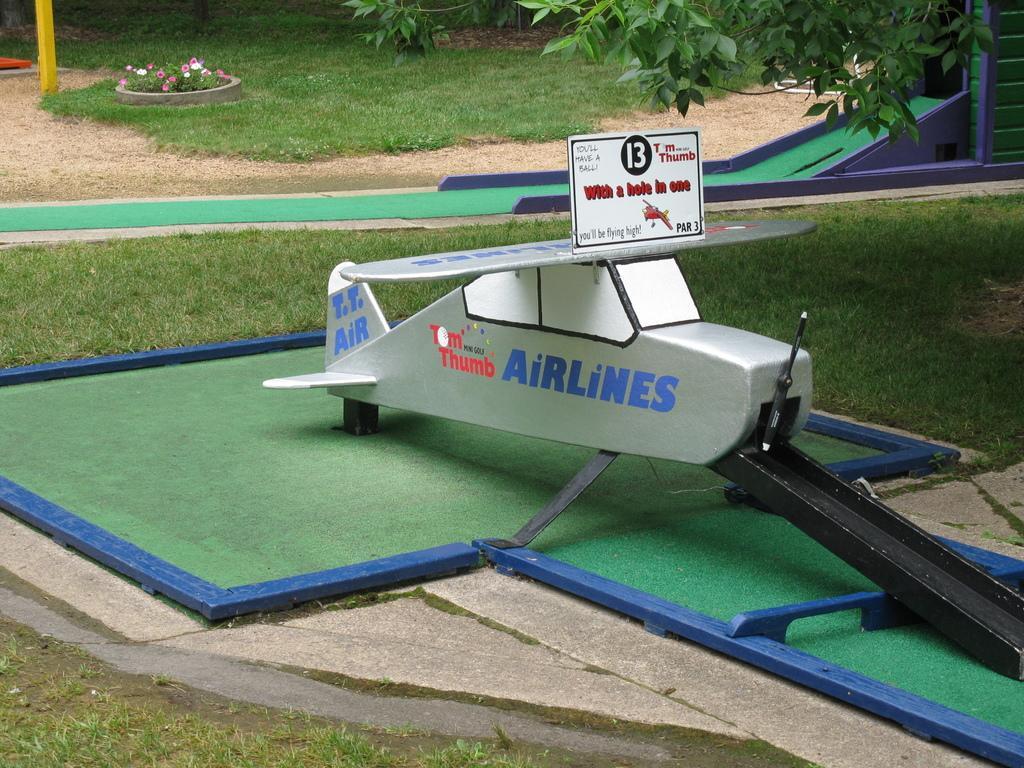Describe this image in one or two sentences. In this image we can see an object and there is some text on it. Behind the object we can see grass and another object and we can see few flowers and plants behind the object. In the top right, we can see the leaves. 